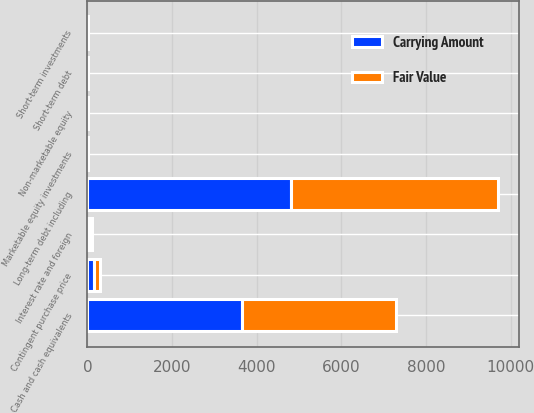Convert chart. <chart><loc_0><loc_0><loc_500><loc_500><stacked_bar_chart><ecel><fcel>Cash and cash equivalents<fcel>Short-term investments<fcel>Marketable equity investments<fcel>Non-marketable equity<fcel>Short-term debt<fcel>Interest rate and foreign<fcel>Contingent purchase price<fcel>Long-term debt including<nl><fcel>Fair Value<fcel>3652.4<fcel>5.5<fcel>1.5<fcel>11.8<fcel>8.1<fcel>52.9<fcel>146.5<fcel>4883.7<nl><fcel>Carrying Amount<fcel>3652.4<fcel>5.5<fcel>1.5<fcel>11.8<fcel>8.1<fcel>52.9<fcel>146.5<fcel>4821.3<nl></chart> 